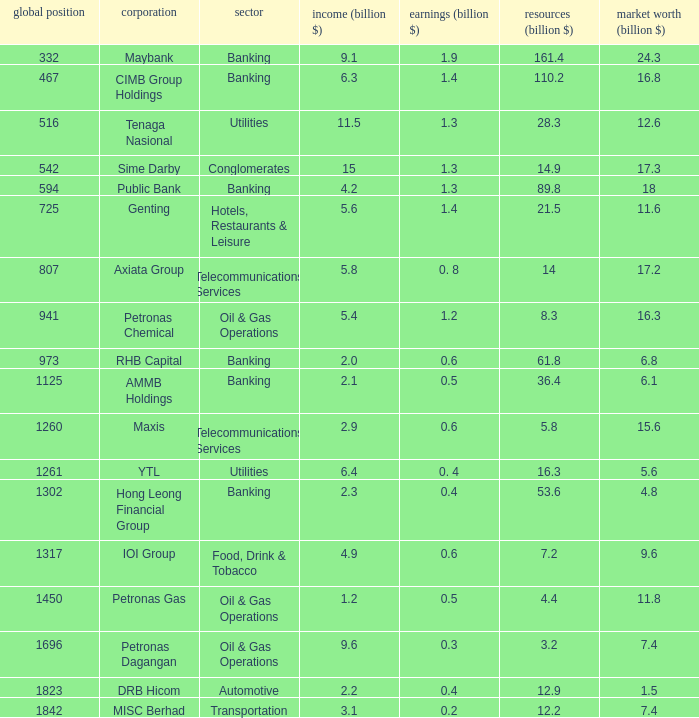Name the world rank for market value 17.2 807.0. 